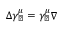<formula> <loc_0><loc_0><loc_500><loc_500>\Delta \gamma _ { \perp } ^ { \mu } = \gamma _ { \perp } ^ { \mu } \nabla</formula> 